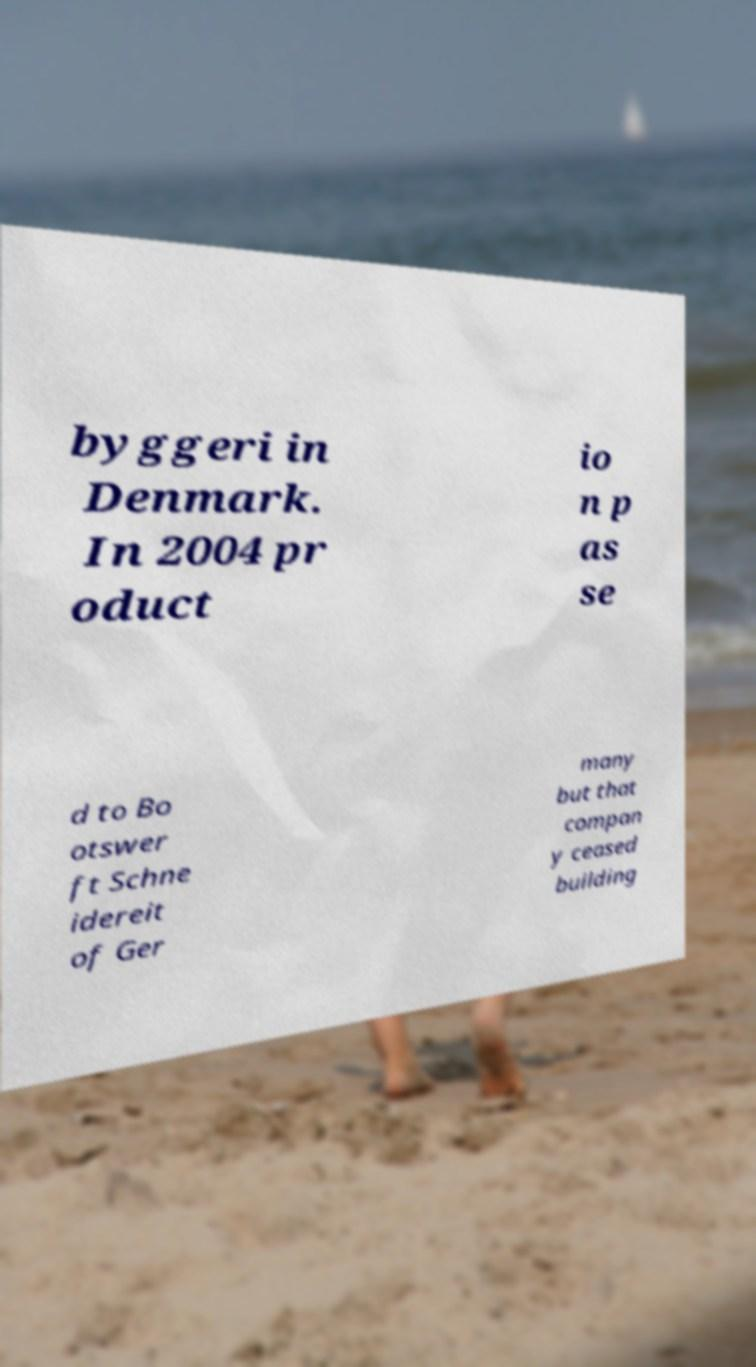For documentation purposes, I need the text within this image transcribed. Could you provide that? byggeri in Denmark. In 2004 pr oduct io n p as se d to Bo otswer ft Schne idereit of Ger many but that compan y ceased building 